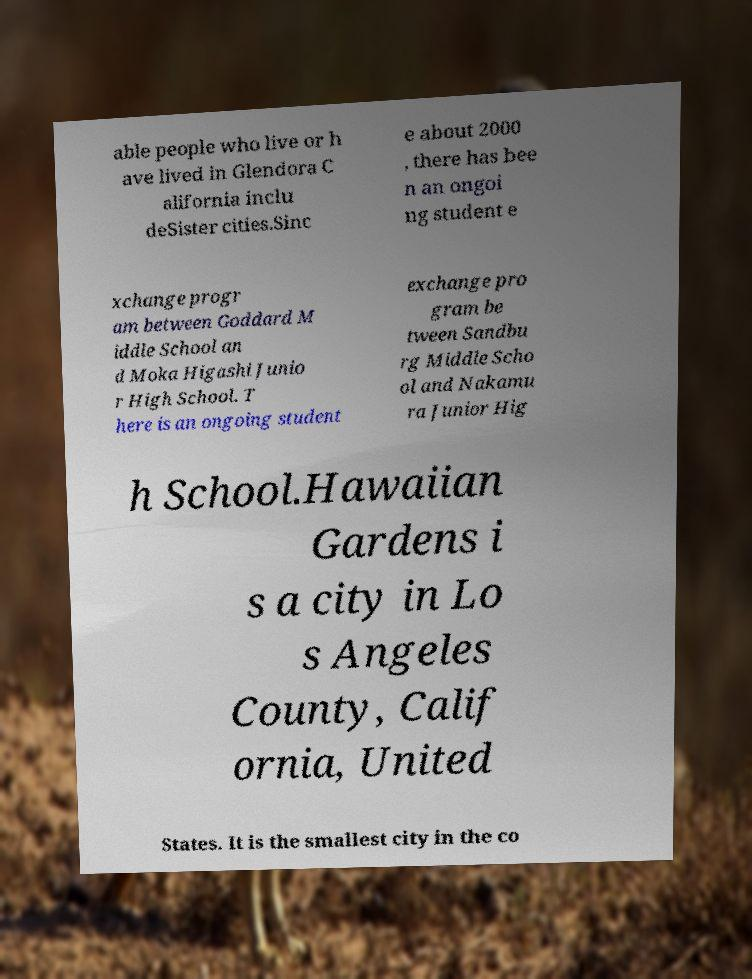I need the written content from this picture converted into text. Can you do that? able people who live or h ave lived in Glendora C alifornia inclu deSister cities.Sinc e about 2000 , there has bee n an ongoi ng student e xchange progr am between Goddard M iddle School an d Moka Higashi Junio r High School. T here is an ongoing student exchange pro gram be tween Sandbu rg Middle Scho ol and Nakamu ra Junior Hig h School.Hawaiian Gardens i s a city in Lo s Angeles County, Calif ornia, United States. It is the smallest city in the co 